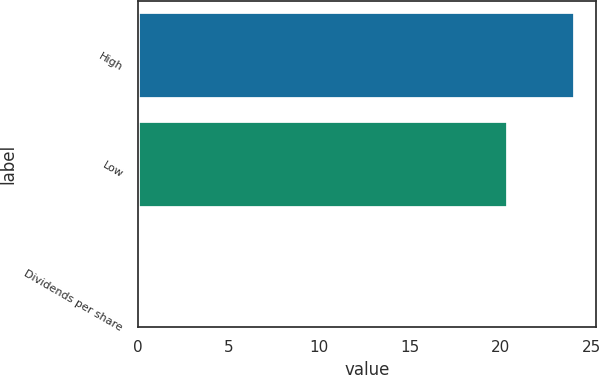Convert chart. <chart><loc_0><loc_0><loc_500><loc_500><bar_chart><fcel>High<fcel>Low<fcel>Dividends per share<nl><fcel>24.06<fcel>20.38<fcel>0.08<nl></chart> 